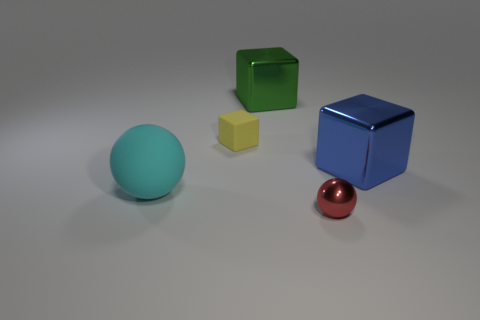Are there more green shiny cubes than tiny blue rubber cylinders?
Keep it short and to the point. Yes. There is a large block that is in front of the big thing behind the yellow rubber object; is there a ball in front of it?
Ensure brevity in your answer.  Yes. What number of other objects are the same size as the green shiny thing?
Offer a very short reply. 2. Are there any blocks in front of the blue shiny block?
Provide a short and direct response. No. There is a metal ball; is it the same color as the large shiny object that is on the left side of the shiny ball?
Your answer should be compact. No. The big metal thing behind the large thing on the right side of the small thing that is to the right of the tiny rubber cube is what color?
Provide a succinct answer. Green. Is there a large green metal object that has the same shape as the big blue object?
Provide a succinct answer. Yes. What color is the block that is the same size as the red thing?
Your response must be concise. Yellow. There is a thing that is in front of the cyan matte sphere; what material is it?
Provide a short and direct response. Metal. Do the big metallic thing right of the big green thing and the tiny thing behind the red shiny object have the same shape?
Make the answer very short. Yes. 